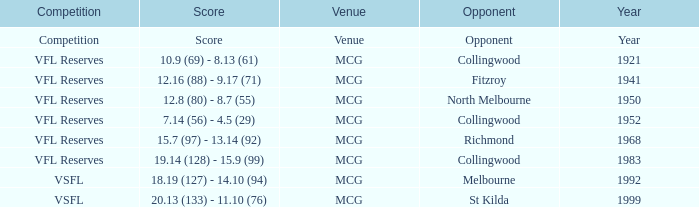In what competition was the score reported as 12.8 (80) - 8.7 (55)? VFL Reserves. 